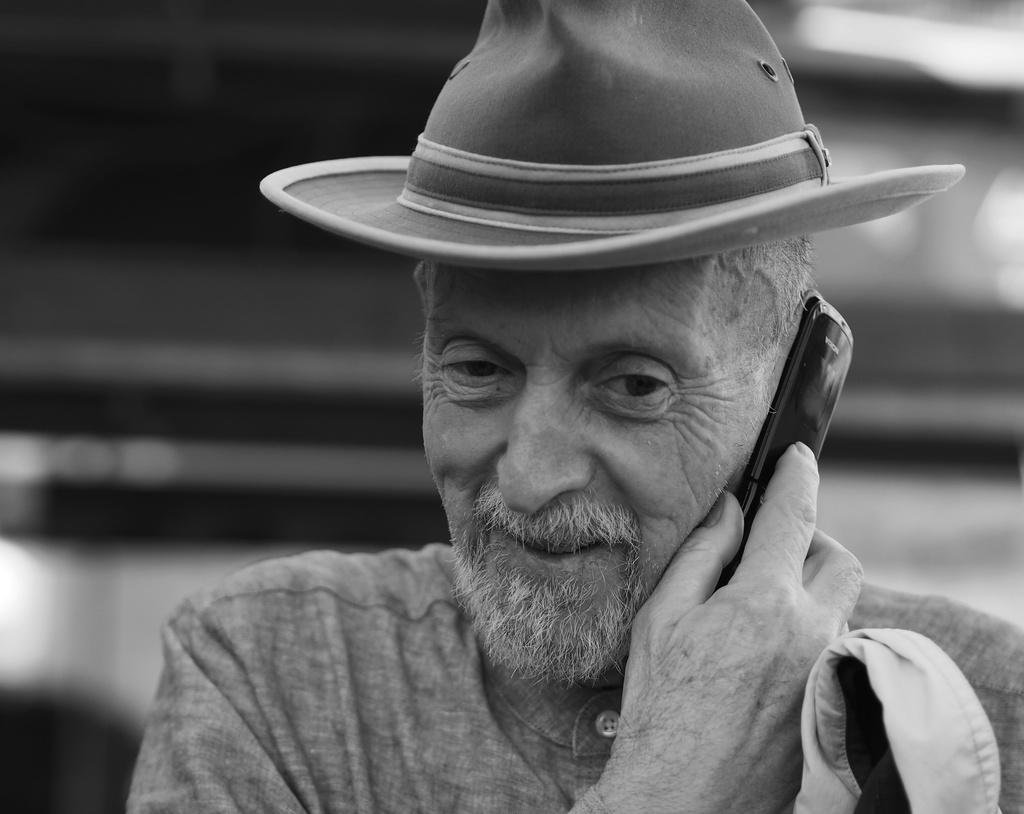What is the color scheme of the image? The image is black and white. Who is present in the image? There is a man in the image. What is the man holding in his hand? The man is holding a mobile in his hand. What type of accessory is the man wearing? The man is wearing a hat. What degree does the man have in the image? There is no information about the man's degree in the image. How much sugar is in the man's coffee in the image? There is no coffee or sugar present in the image. 